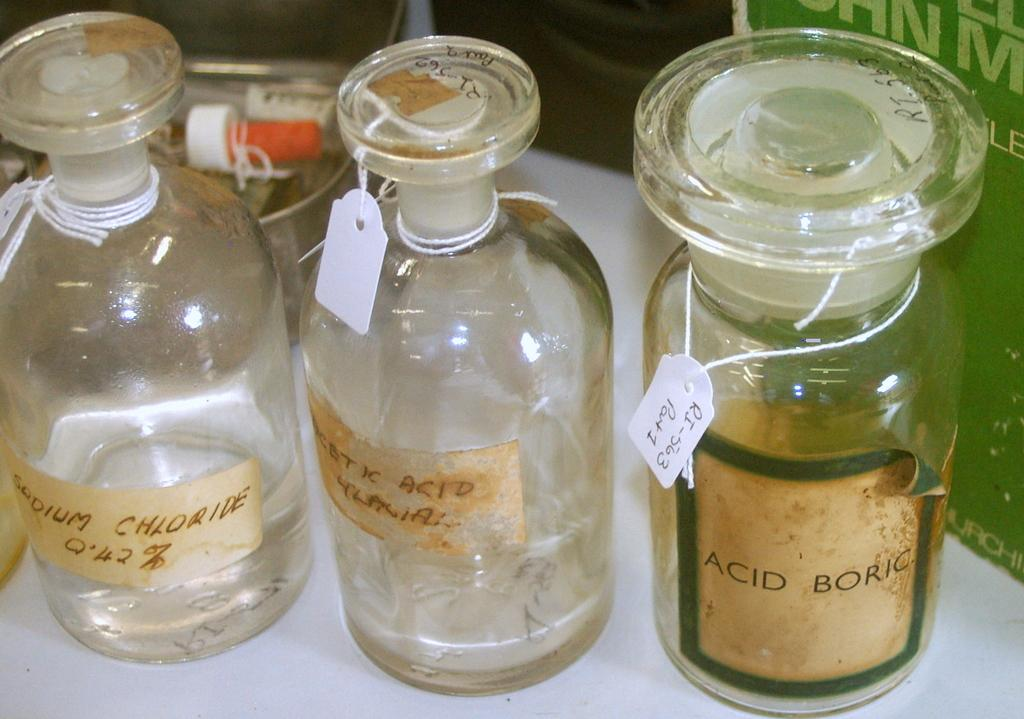Provide a one-sentence caption for the provided image. Old chemical bottles are lined up on a table, including one labeled ACID BORIC. 